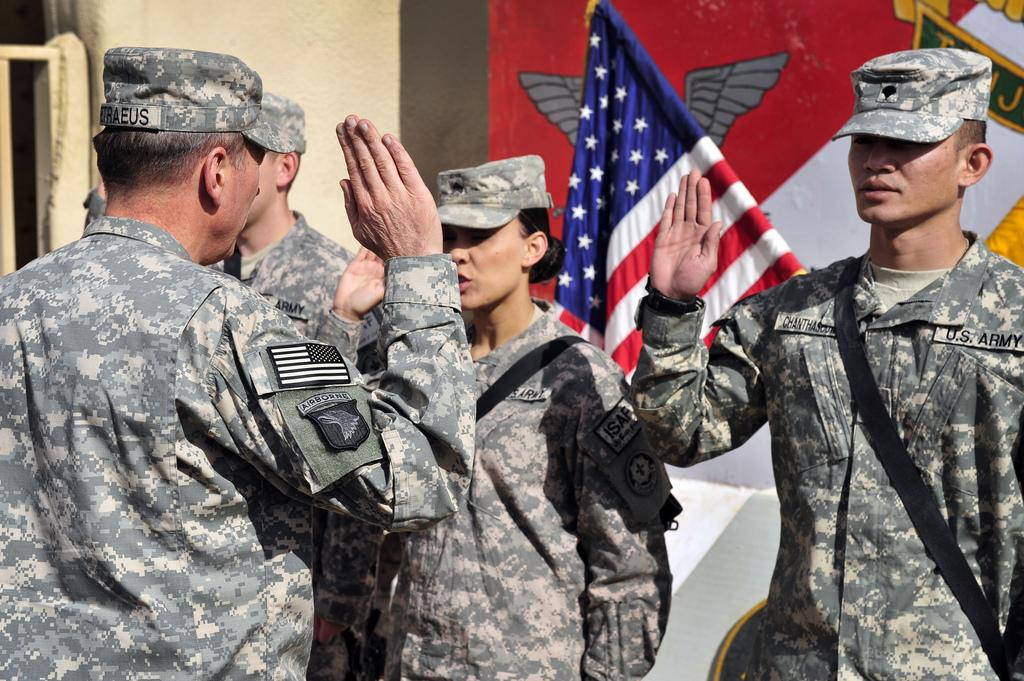How many people are in the foreground of the image? There are four people in the foreground of the image. What are the people wearing in the image? The people are wearing military dress. What action are the people performing in the image? The people are raising a palm in the air. What can be seen in the background of the image? There is a flag in the background of the image. What architectural feature is visible at the top of the image? There appears to be a wall at the top of the image. How many frogs are sitting on the wall in the image? There are no frogs present in the image; the wall is part of the architectural feature visible at the top of the image. What type of bird can be seen perched on the flag in the image? There are no birds visible in the image, as the focus is on the people and their actions, as well as the flag and wall in the background. 